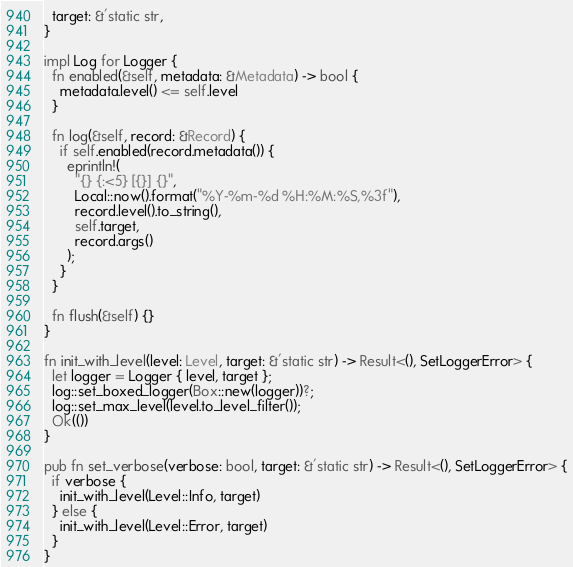<code> <loc_0><loc_0><loc_500><loc_500><_Rust_>  target: &'static str,
}

impl Log for Logger {
  fn enabled(&self, metadata: &Metadata) -> bool {
    metadata.level() <= self.level
  }

  fn log(&self, record: &Record) {
    if self.enabled(record.metadata()) {
      eprintln!(
        "{} {:<5} [{}] {}",
        Local::now().format("%Y-%m-%d %H:%M:%S,%3f"),
        record.level().to_string(),
        self.target,
        record.args()
      );
    }
  }

  fn flush(&self) {}
}

fn init_with_level(level: Level, target: &'static str) -> Result<(), SetLoggerError> {
  let logger = Logger { level, target };
  log::set_boxed_logger(Box::new(logger))?;
  log::set_max_level(level.to_level_filter());
  Ok(())
}

pub fn set_verbose(verbose: bool, target: &'static str) -> Result<(), SetLoggerError> {
  if verbose {
    init_with_level(Level::Info, target)
  } else {
    init_with_level(Level::Error, target)
  }
}
</code> 